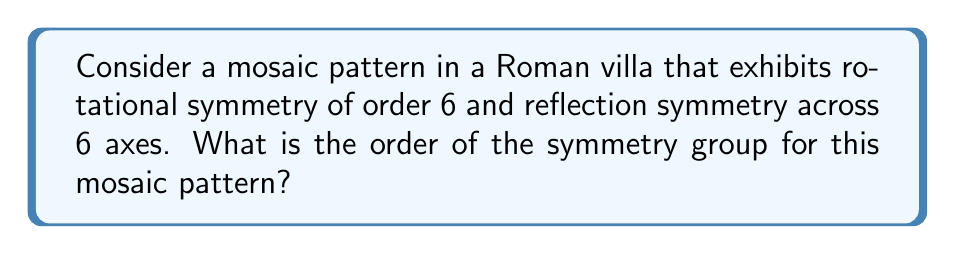Can you solve this math problem? To solve this problem, we need to understand the concept of symmetry groups in the context of plane symmetry patterns:

1. Rotational symmetry: The pattern can be rotated by $\frac{360°}{6} = 60°$ and remain unchanged. This gives us 6 rotational symmetries (including the identity rotation of 0°).

2. Reflection symmetry: The pattern has 6 axes of reflection.

3. Symmetry group: The symmetry group consists of all transformations that leave the pattern unchanged. In this case, it includes rotations and reflections.

4. Dihedral group: The symmetry group described here is known as the dihedral group $D_6$.

To calculate the order of the symmetry group:

a) Number of rotational symmetries: 6
b) Number of reflection symmetries: 6
c) Total number of symmetries: 6 + 6 = 12

The order of a group is the number of elements in the group. Therefore, the order of the symmetry group for this mosaic pattern is 12.

This can also be derived from the general formula for the order of a dihedral group $D_n$:

$$|D_n| = 2n$$

Where $n$ is the order of rotational symmetry. In this case:

$$|D_6| = 2 \cdot 6 = 12$$
Answer: The order of the symmetry group for this Roman mosaic pattern is 12. 